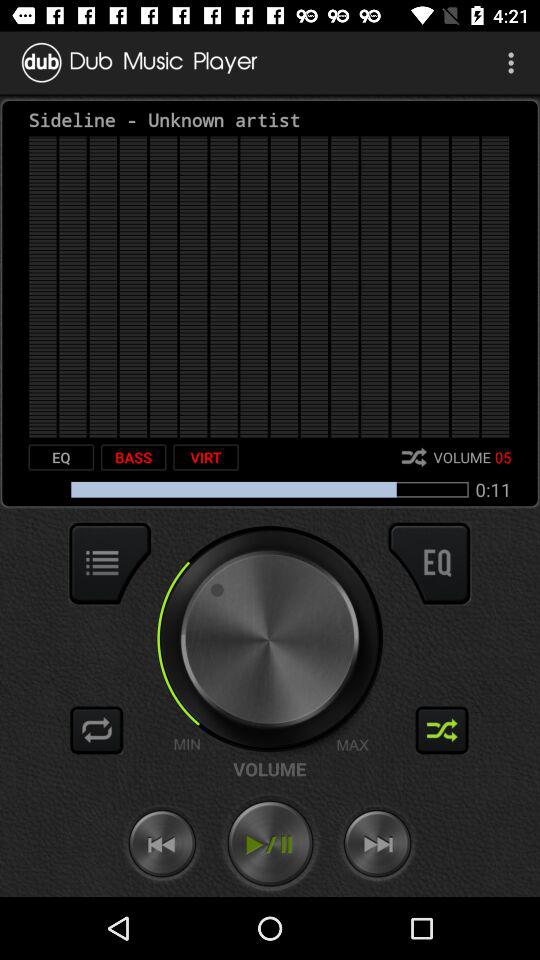Which track is currently playing? The currently playing track is "Sideline". 